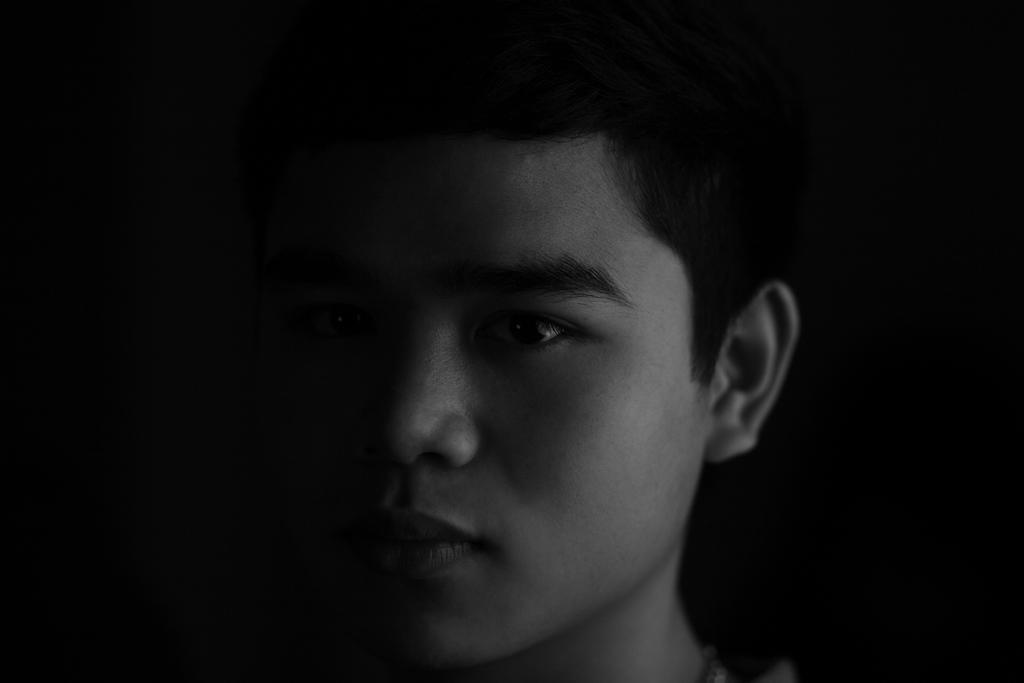How would you summarize this image in a sentence or two? In this picture I can see a man and I can see dark background. 